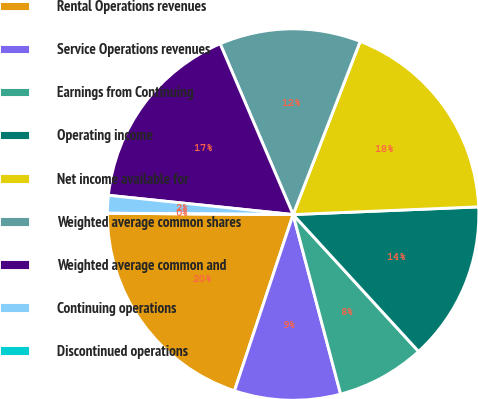<chart> <loc_0><loc_0><loc_500><loc_500><pie_chart><fcel>Rental Operations revenues<fcel>Service Operations revenues<fcel>Earnings from Continuing<fcel>Operating income<fcel>Net income available for<fcel>Weighted average common shares<fcel>Weighted average common and<fcel>Continuing operations<fcel>Discontinued operations<nl><fcel>20.0%<fcel>9.23%<fcel>7.69%<fcel>13.85%<fcel>18.46%<fcel>12.31%<fcel>16.92%<fcel>1.54%<fcel>0.0%<nl></chart> 